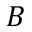<formula> <loc_0><loc_0><loc_500><loc_500>B</formula> 